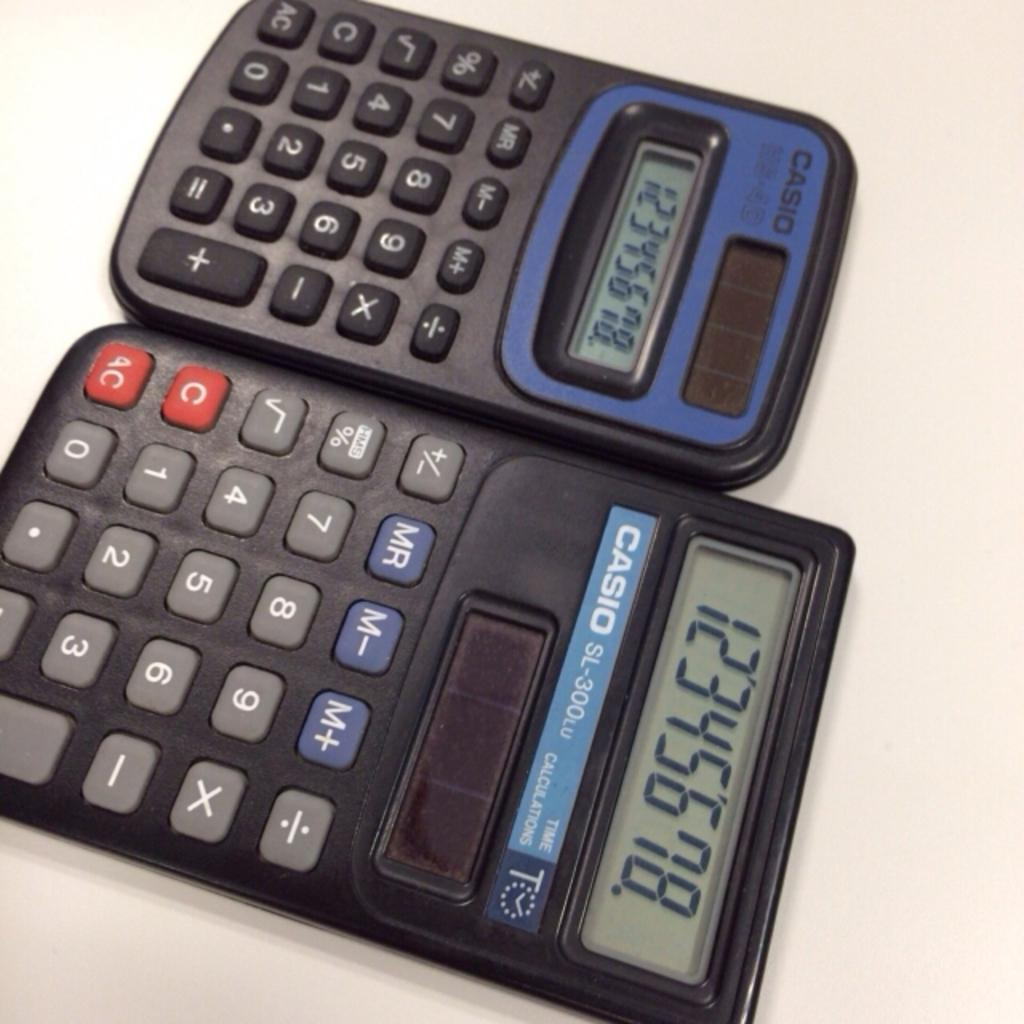<image>
Present a compact description of the photo's key features. two calculators next to one another with the label 'casio' on them 